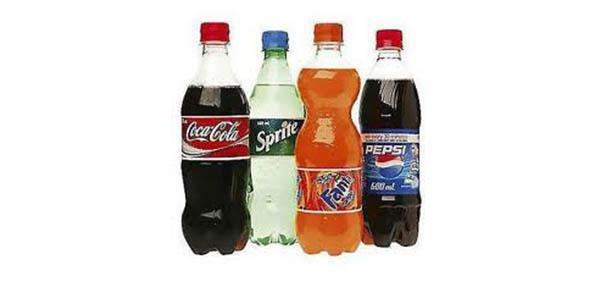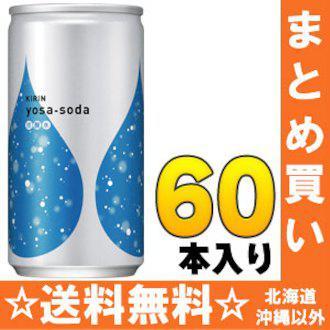The first image is the image on the left, the second image is the image on the right. For the images shown, is this caption "There are fewer than seven bottles in total." true? Answer yes or no. Yes. The first image is the image on the left, the second image is the image on the right. Evaluate the accuracy of this statement regarding the images: "No image contains more than four bottles, and the left image shows a row of three bottles that aren't overlapping.". Is it true? Answer yes or no. No. 